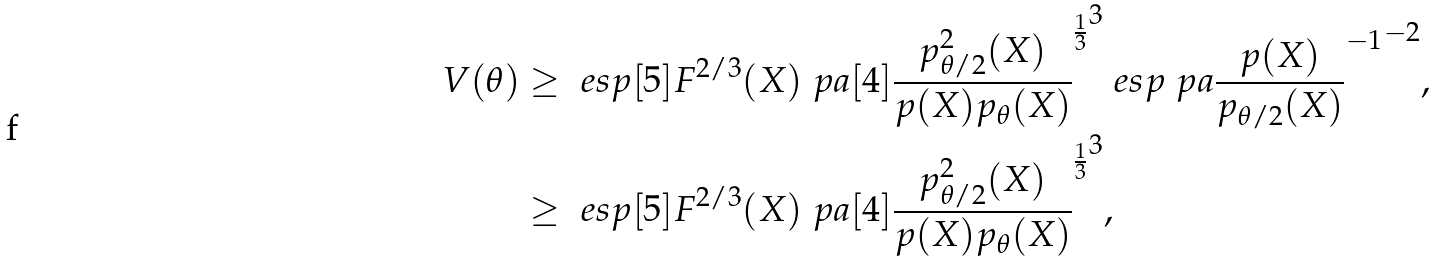<formula> <loc_0><loc_0><loc_500><loc_500>V ( \theta ) & \geq \ e s p [ 5 ] { F ^ { 2 / 3 } ( X ) \ p a [ 4 ] { \frac { p ^ { 2 } _ { \theta / 2 } ( X ) } { p ( X ) p _ { \theta } ( X ) } } ^ { \frac { 1 } { 3 } } } ^ { 3 } \ e s p { \ p a { \frac { p ( X ) } { p _ { \theta / 2 } ( X ) } } ^ { - 1 } } ^ { - 2 } , \\ & \geq \ e s p [ 5 ] { F ^ { 2 / 3 } ( X ) \ p a [ 4 ] { \frac { p ^ { 2 } _ { \theta / 2 } ( X ) } { p ( X ) p _ { \theta } ( X ) } } ^ { \frac { 1 } { 3 } } } ^ { 3 } ,</formula> 